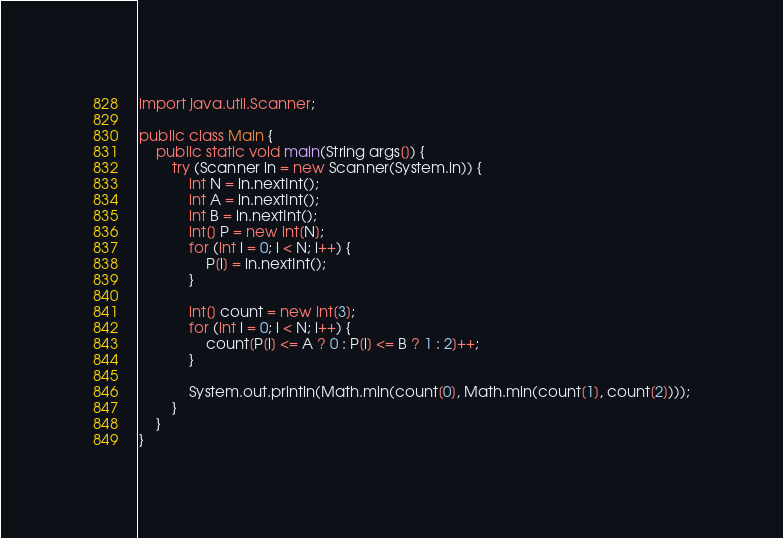Convert code to text. <code><loc_0><loc_0><loc_500><loc_500><_Java_>import java.util.Scanner;

public class Main {
    public static void main(String args[]) {
        try (Scanner in = new Scanner(System.in)) {
            int N = in.nextInt();
            int A = in.nextInt();
            int B = in.nextInt();
            int[] P = new int[N];
            for (int i = 0; i < N; i++) {
                P[i] = in.nextInt();
            }

            int[] count = new int[3];
            for (int i = 0; i < N; i++) {
                count[P[i] <= A ? 0 : P[i] <= B ? 1 : 2]++;
            }

            System.out.println(Math.min(count[0], Math.min(count[1], count[2])));
        }
    }
}
</code> 